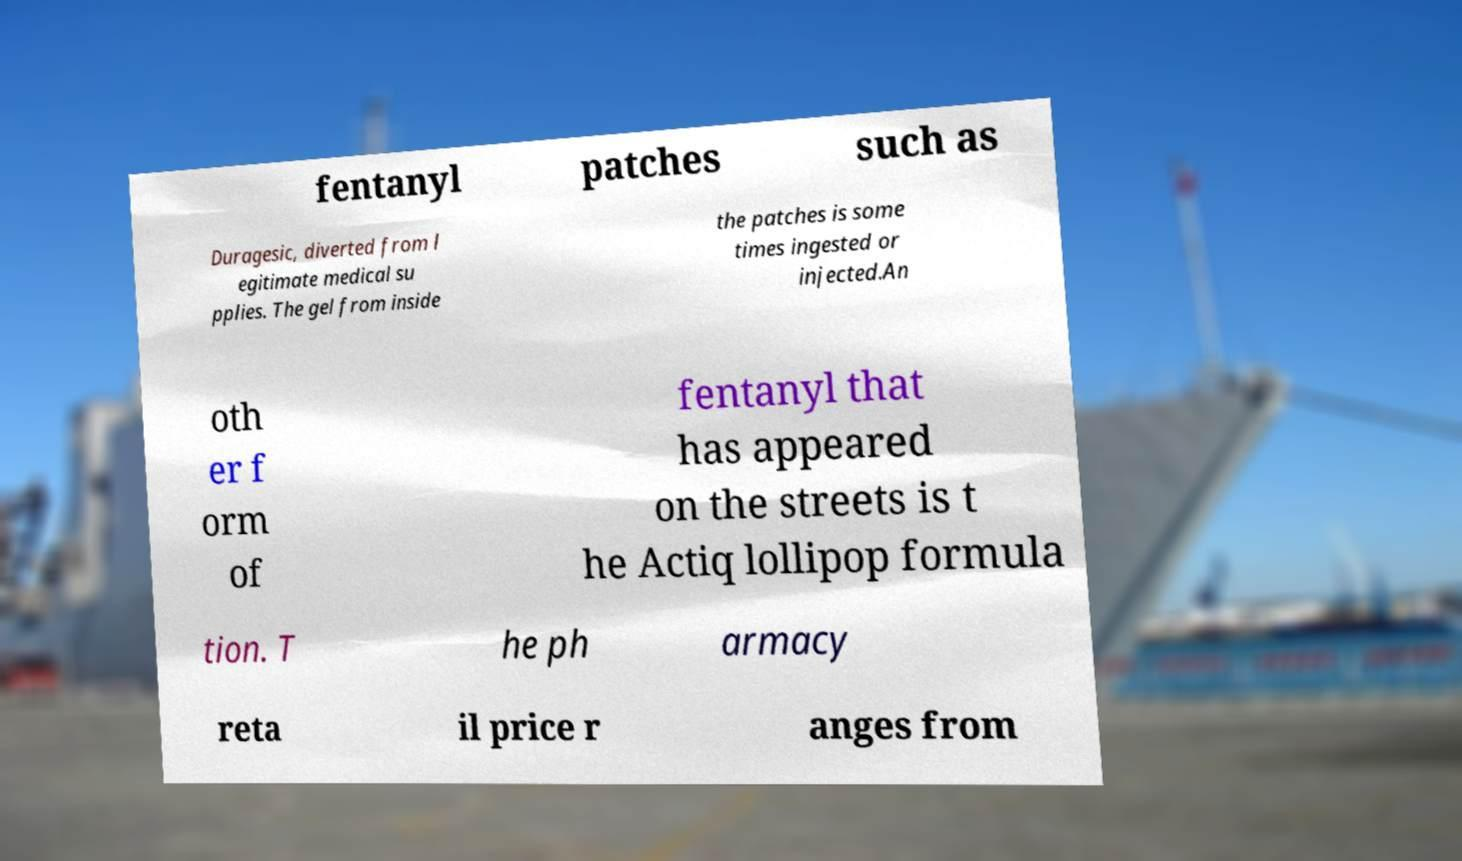Could you assist in decoding the text presented in this image and type it out clearly? fentanyl patches such as Duragesic, diverted from l egitimate medical su pplies. The gel from inside the patches is some times ingested or injected.An oth er f orm of fentanyl that has appeared on the streets is t he Actiq lollipop formula tion. T he ph armacy reta il price r anges from 